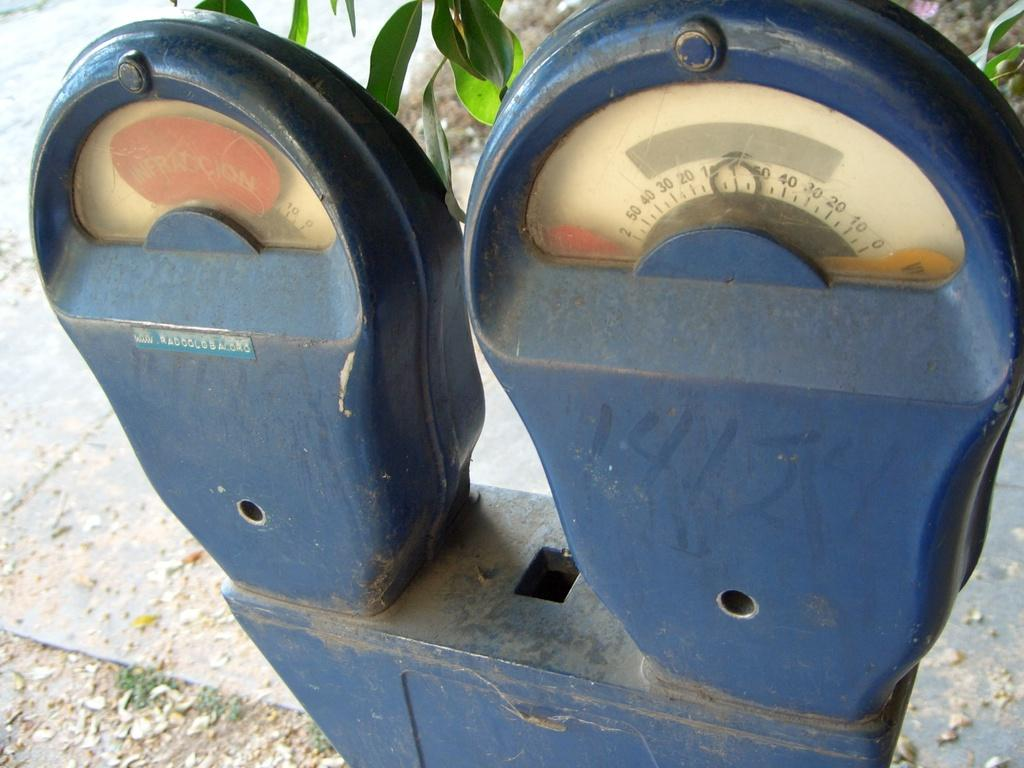<image>
Render a clear and concise summary of the photo. A parking meter displays a red sign that says Infraction on it. 